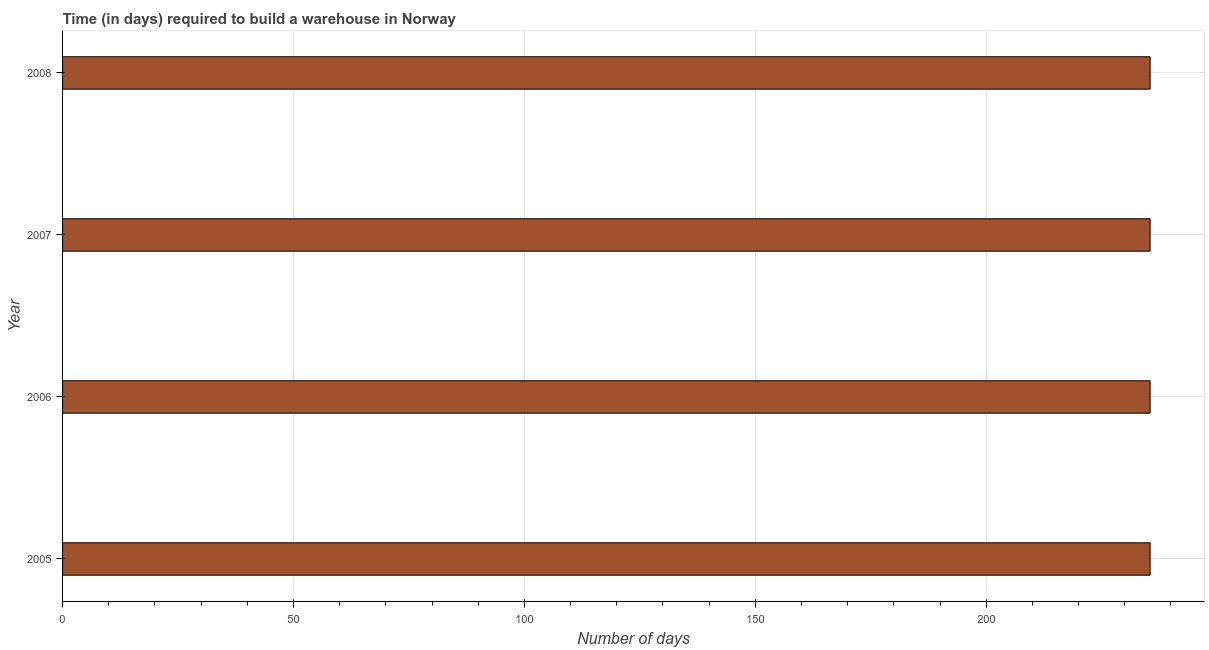Does the graph contain any zero values?
Your answer should be compact. No. What is the title of the graph?
Your answer should be very brief. Time (in days) required to build a warehouse in Norway. What is the label or title of the X-axis?
Keep it short and to the point. Number of days. What is the label or title of the Y-axis?
Ensure brevity in your answer.  Year. What is the time required to build a warehouse in 2008?
Your answer should be very brief. 235.5. Across all years, what is the maximum time required to build a warehouse?
Give a very brief answer. 235.5. Across all years, what is the minimum time required to build a warehouse?
Your response must be concise. 235.5. What is the sum of the time required to build a warehouse?
Ensure brevity in your answer.  942. What is the average time required to build a warehouse per year?
Make the answer very short. 235.5. What is the median time required to build a warehouse?
Your response must be concise. 235.5. Do a majority of the years between 2008 and 2005 (inclusive) have time required to build a warehouse greater than 50 days?
Offer a terse response. Yes. Is the time required to build a warehouse in 2005 less than that in 2007?
Provide a succinct answer. No. Is the difference between the time required to build a warehouse in 2005 and 2007 greater than the difference between any two years?
Your answer should be very brief. Yes. What is the difference between the highest and the second highest time required to build a warehouse?
Offer a terse response. 0. How many bars are there?
Your answer should be compact. 4. How many years are there in the graph?
Offer a very short reply. 4. What is the Number of days of 2005?
Offer a very short reply. 235.5. What is the Number of days of 2006?
Keep it short and to the point. 235.5. What is the Number of days of 2007?
Offer a terse response. 235.5. What is the Number of days of 2008?
Make the answer very short. 235.5. What is the difference between the Number of days in 2006 and 2008?
Your answer should be compact. 0. What is the ratio of the Number of days in 2005 to that in 2006?
Offer a very short reply. 1. What is the ratio of the Number of days in 2005 to that in 2007?
Provide a succinct answer. 1. What is the ratio of the Number of days in 2006 to that in 2007?
Give a very brief answer. 1. What is the ratio of the Number of days in 2006 to that in 2008?
Your answer should be compact. 1. What is the ratio of the Number of days in 2007 to that in 2008?
Offer a very short reply. 1. 